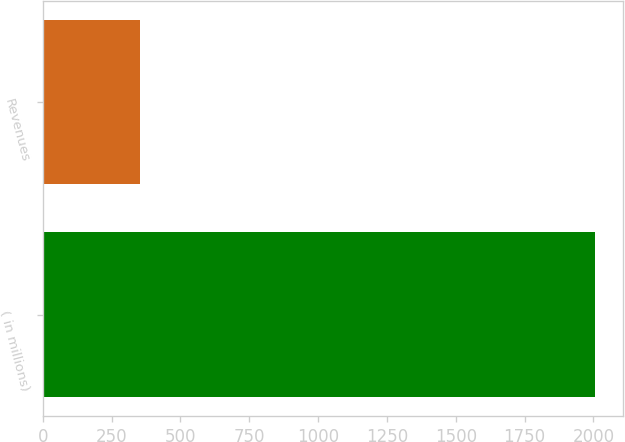Convert chart to OTSL. <chart><loc_0><loc_0><loc_500><loc_500><bar_chart><fcel>( in millions)<fcel>Revenues<nl><fcel>2006<fcel>353<nl></chart> 